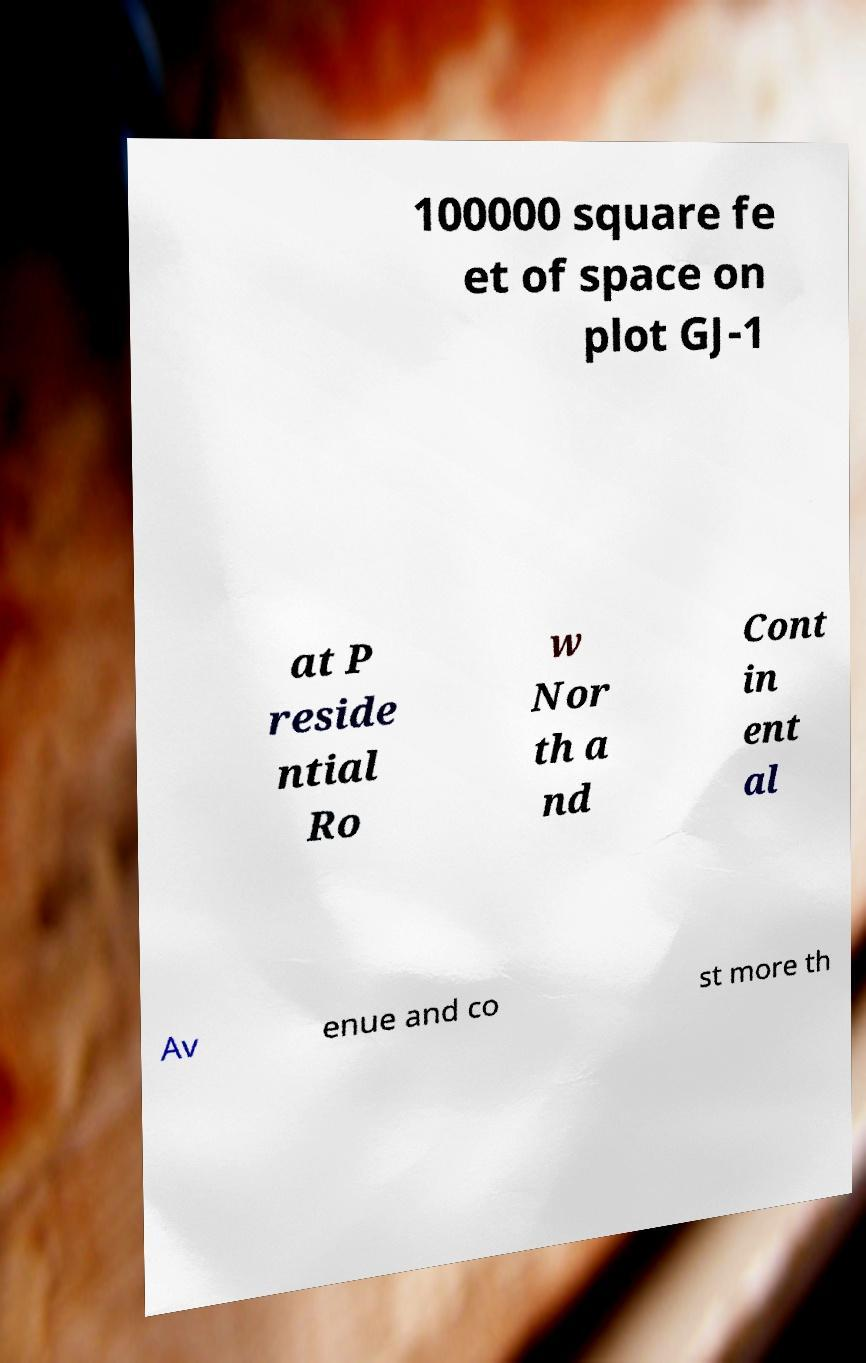Could you assist in decoding the text presented in this image and type it out clearly? 100000 square fe et of space on plot GJ-1 at P reside ntial Ro w Nor th a nd Cont in ent al Av enue and co st more th 